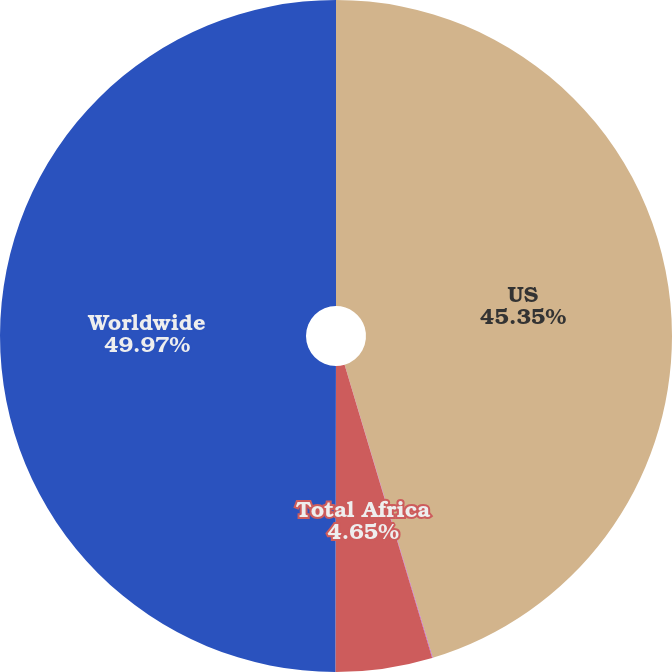Convert chart. <chart><loc_0><loc_0><loc_500><loc_500><pie_chart><fcel>US<fcel>Other Africa<fcel>Total Africa<fcel>Worldwide<nl><fcel>45.35%<fcel>0.03%<fcel>4.65%<fcel>49.97%<nl></chart> 